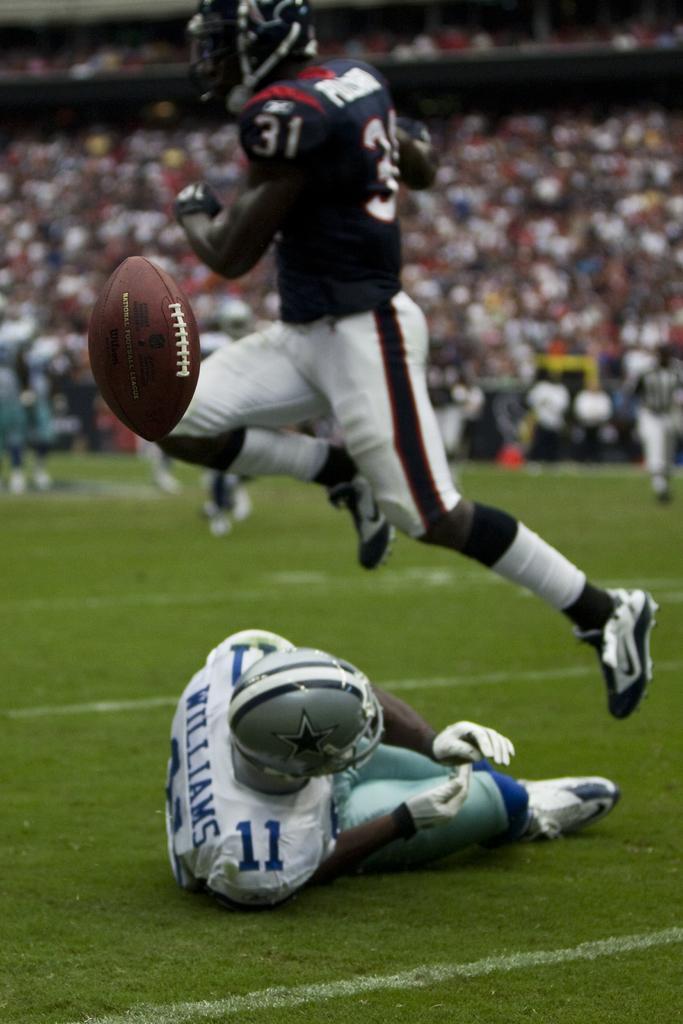Please provide a concise description of this image. In the image there is a person on sports dress and helmet lying on grass floor and another person jumping above him with rugby ball, in the back there are few persons standing, over the whole background there are many people sitting and looking at the game. 